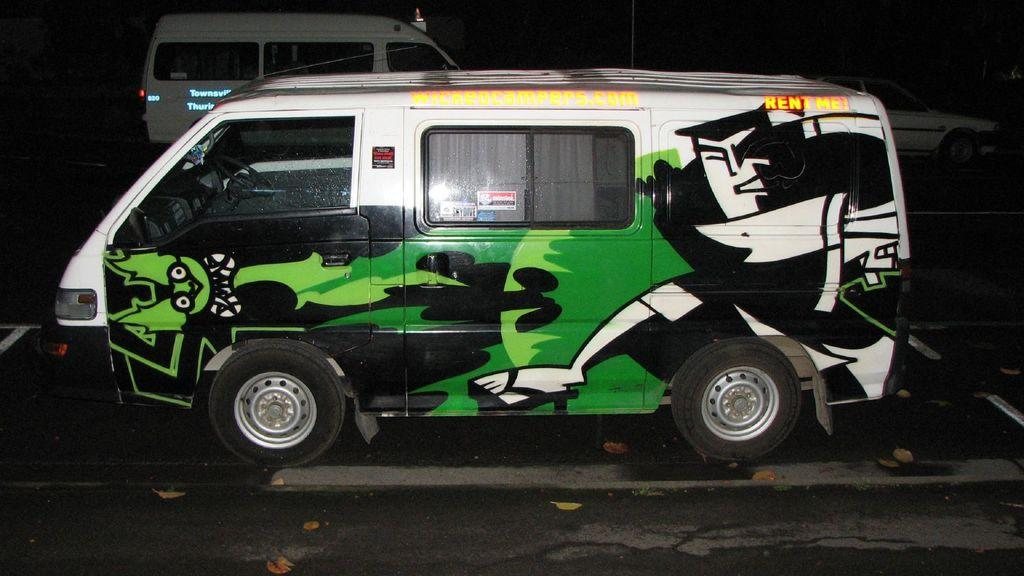What type of vehicles can be seen on the road in the image? There are motor vehicles on the road in the image. How many letters can be seen on the bee in the image? There is no bee present in the image, and therefore no letters can be seen on it. 